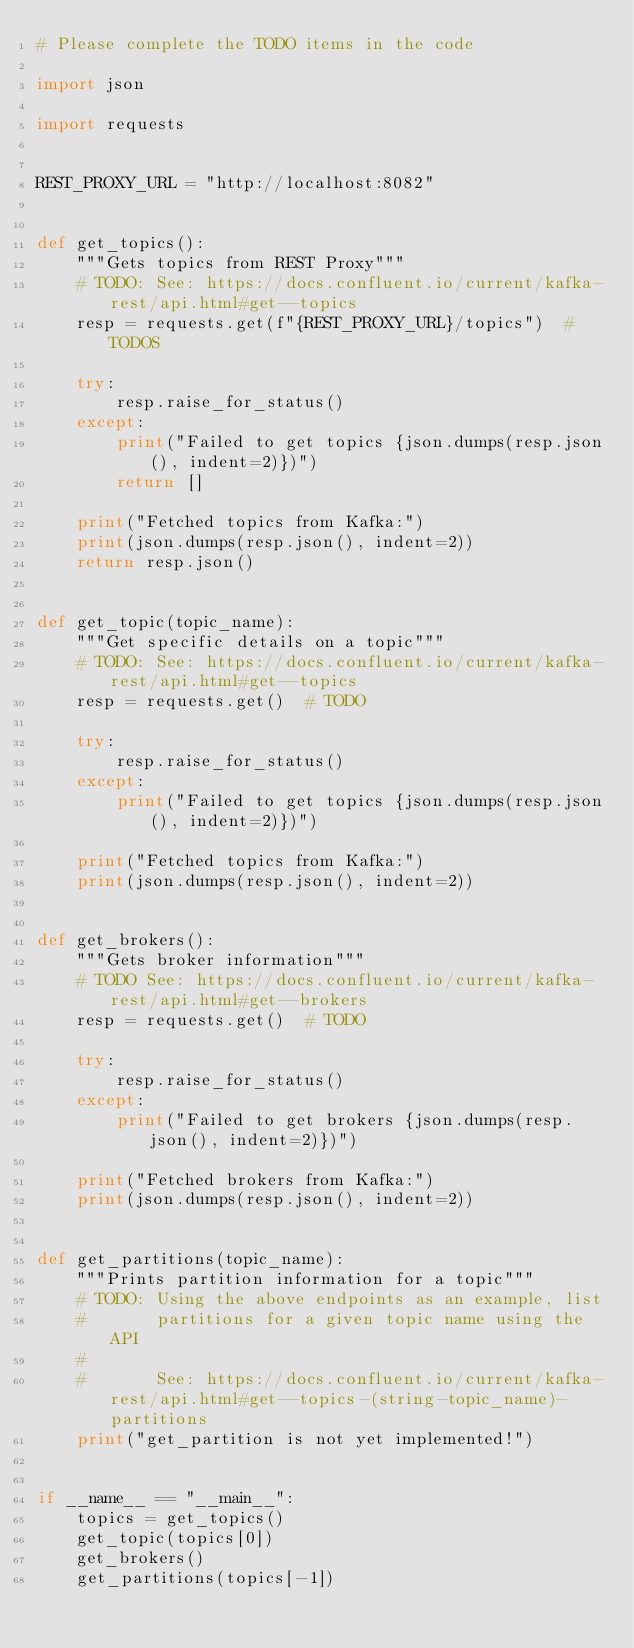Convert code to text. <code><loc_0><loc_0><loc_500><loc_500><_Python_># Please complete the TODO items in the code

import json

import requests


REST_PROXY_URL = "http://localhost:8082"


def get_topics():
    """Gets topics from REST Proxy"""
    # TODO: See: https://docs.confluent.io/current/kafka-rest/api.html#get--topics
    resp = requests.get(f"{REST_PROXY_URL}/topics")  # TODOS

    try:
        resp.raise_for_status()
    except:
        print("Failed to get topics {json.dumps(resp.json(), indent=2)})")
        return []

    print("Fetched topics from Kafka:")
    print(json.dumps(resp.json(), indent=2))
    return resp.json()


def get_topic(topic_name):
    """Get specific details on a topic"""
    # TODO: See: https://docs.confluent.io/current/kafka-rest/api.html#get--topics
    resp = requests.get()  # TODO

    try:
        resp.raise_for_status()
    except:
        print("Failed to get topics {json.dumps(resp.json(), indent=2)})")

    print("Fetched topics from Kafka:")
    print(json.dumps(resp.json(), indent=2))


def get_brokers():
    """Gets broker information"""
    # TODO See: https://docs.confluent.io/current/kafka-rest/api.html#get--brokers
    resp = requests.get()  # TODO

    try:
        resp.raise_for_status()
    except:
        print("Failed to get brokers {json.dumps(resp.json(), indent=2)})")

    print("Fetched brokers from Kafka:")
    print(json.dumps(resp.json(), indent=2))


def get_partitions(topic_name):
    """Prints partition information for a topic"""
    # TODO: Using the above endpoints as an example, list
    #       partitions for a given topic name using the API
    #
    #       See: https://docs.confluent.io/current/kafka-rest/api.html#get--topics-(string-topic_name)-partitions
    print("get_partition is not yet implemented!")


if __name__ == "__main__":
    topics = get_topics()
    get_topic(topics[0])
    get_brokers()
    get_partitions(topics[-1])
</code> 